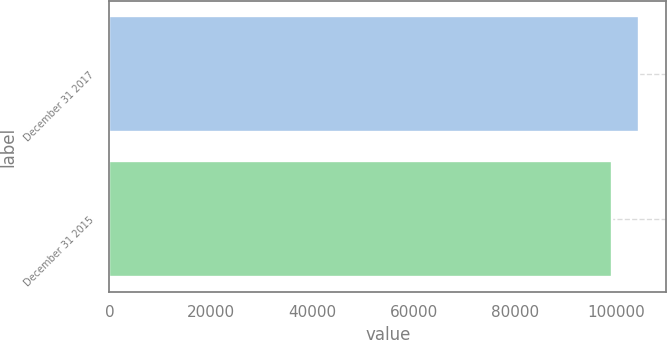Convert chart to OTSL. <chart><loc_0><loc_0><loc_500><loc_500><bar_chart><fcel>December 31 2017<fcel>December 31 2015<nl><fcel>104520<fcel>99141<nl></chart> 